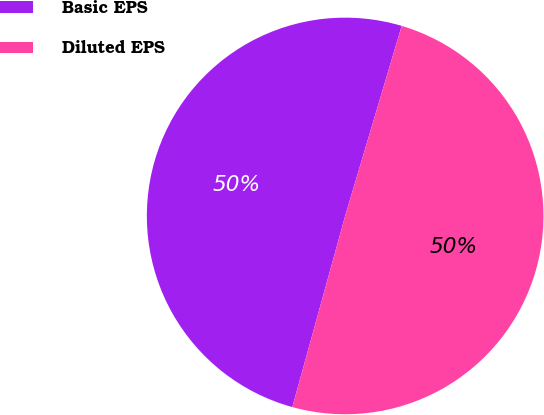Convert chart. <chart><loc_0><loc_0><loc_500><loc_500><pie_chart><fcel>Basic EPS<fcel>Diluted EPS<nl><fcel>50.31%<fcel>49.69%<nl></chart> 